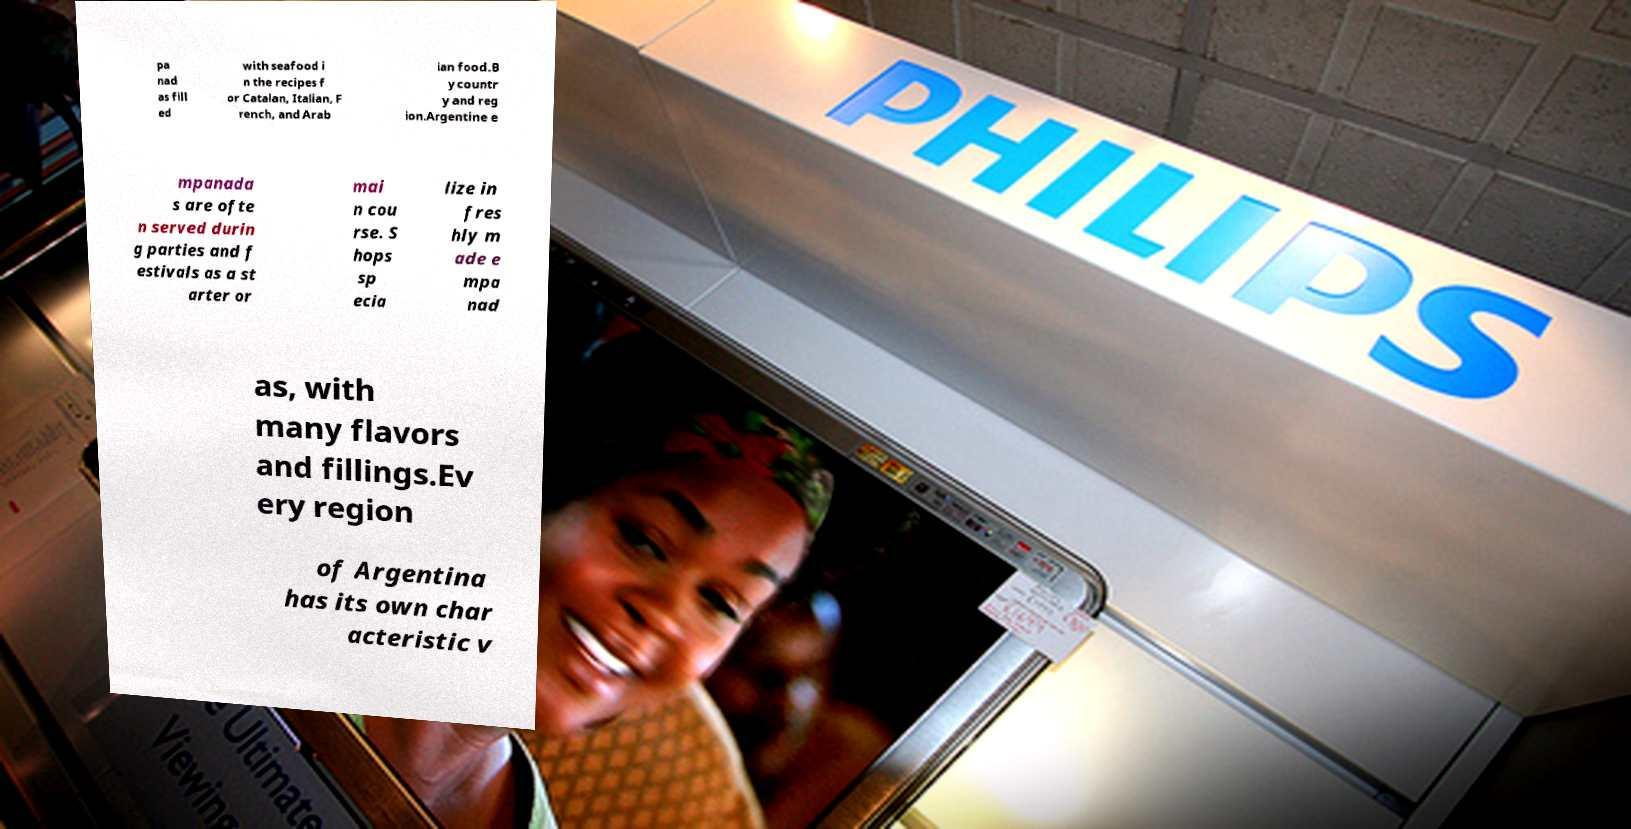What messages or text are displayed in this image? I need them in a readable, typed format. pa nad as fill ed with seafood i n the recipes f or Catalan, Italian, F rench, and Arab ian food.B y countr y and reg ion.Argentine e mpanada s are ofte n served durin g parties and f estivals as a st arter or mai n cou rse. S hops sp ecia lize in fres hly m ade e mpa nad as, with many flavors and fillings.Ev ery region of Argentina has its own char acteristic v 